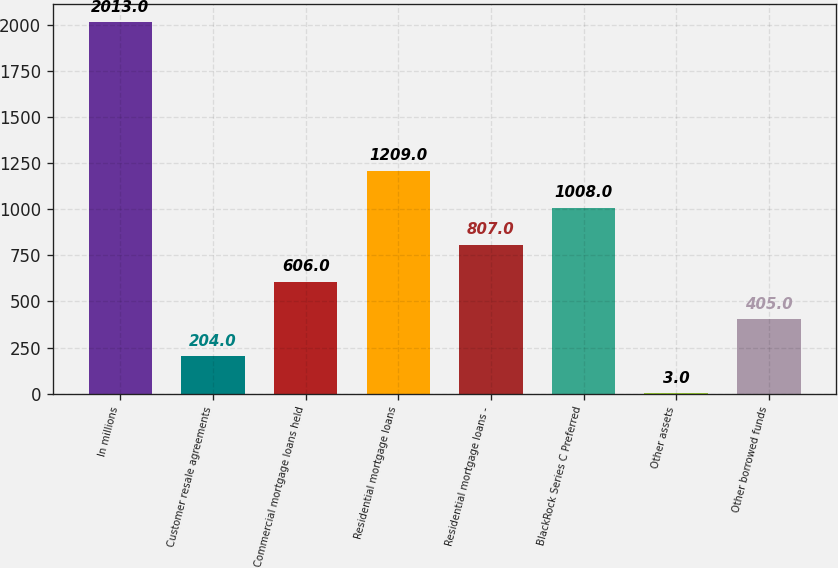Convert chart. <chart><loc_0><loc_0><loc_500><loc_500><bar_chart><fcel>In millions<fcel>Customer resale agreements<fcel>Commercial mortgage loans held<fcel>Residential mortgage loans<fcel>Residential mortgage loans -<fcel>BlackRock Series C Preferred<fcel>Other assets<fcel>Other borrowed funds<nl><fcel>2013<fcel>204<fcel>606<fcel>1209<fcel>807<fcel>1008<fcel>3<fcel>405<nl></chart> 